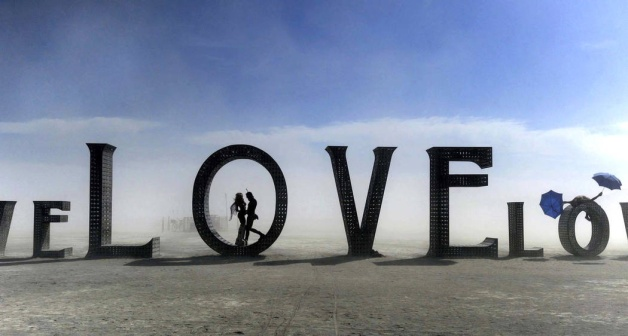What do you see happening in this image? The image captures a poignant scene in an expansive desert-like area, where a large installation of the word "LOVE" serves as a striking backdrop. Two people are in the foreground, closely embracing within the concave space of the 'O', highlighting a moment of intimacy and connection. Constructed from what appears to be weathered wooden crates, each letter of the installation provides a rugged contrast to the smooth, vast landscape around it. On the far right, another individual, barely noticeable and seemingly mundane in action, carries an umbrella, adding a layer of solitude and contemplation to the scene, possibly hinting at themes of loneliness versus companionship. The sky, mildly hazy, reinforces a serene yet somber mood to the setting. 